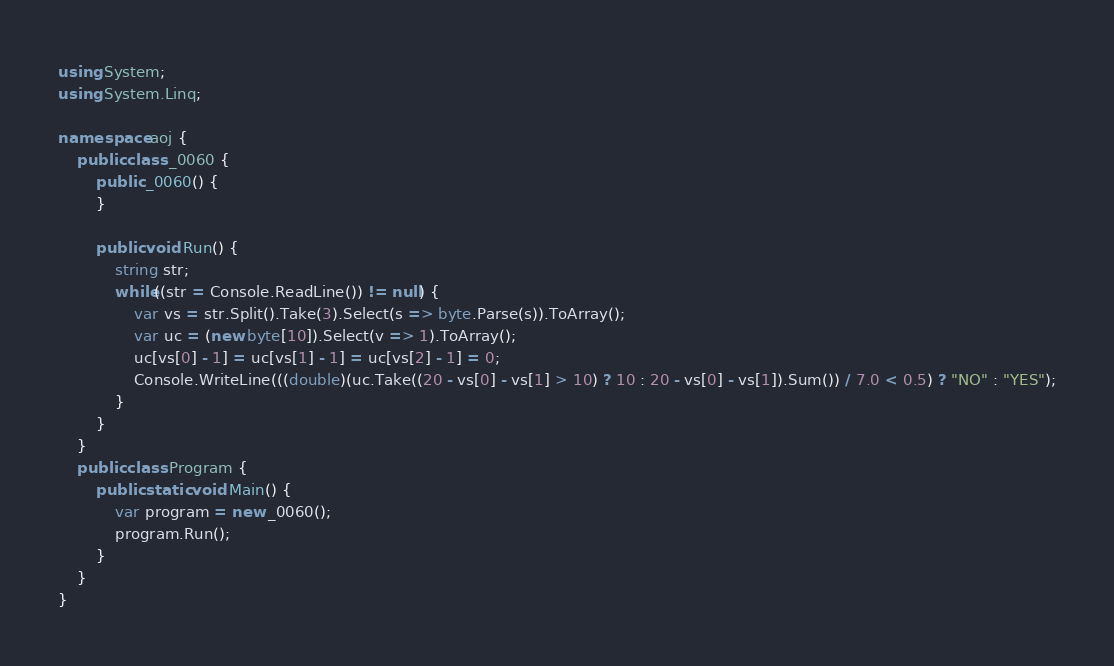<code> <loc_0><loc_0><loc_500><loc_500><_C#_>using System;
using System.Linq;

namespace aoj {
	public class _0060 {
		public _0060() {
		}

		public void Run() {
			string str;
			while((str = Console.ReadLine()) != null) {
				var vs = str.Split().Take(3).Select(s => byte.Parse(s)).ToArray();
				var uc = (new byte[10]).Select(v => 1).ToArray();
				uc[vs[0] - 1] = uc[vs[1] - 1] = uc[vs[2] - 1] = 0;
				Console.WriteLine(((double)(uc.Take((20 - vs[0] - vs[1] > 10) ? 10 : 20 - vs[0] - vs[1]).Sum()) / 7.0 < 0.5) ? "NO" : "YES");
			}
		}
	}
	public class Program {
		public static void Main() {
			var program = new _0060();
			program.Run();
		}
	}
}</code> 